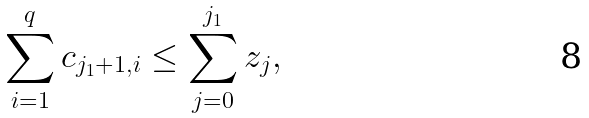Convert formula to latex. <formula><loc_0><loc_0><loc_500><loc_500>\sum _ { i = 1 } ^ { q } c _ { j _ { 1 } + 1 , i } \leq \sum _ { j = 0 } ^ { j _ { 1 } } z _ { j } ,</formula> 